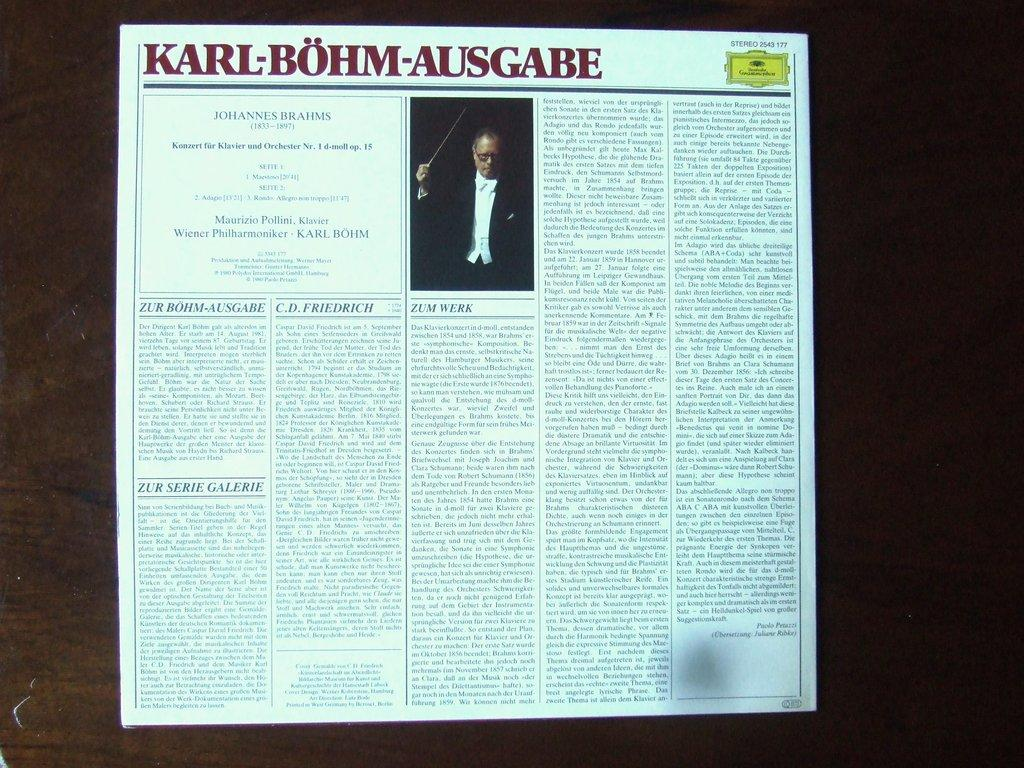What is the main subject in the center of the image? There is a newspaper in the center of the image. What can be found within the newspaper? There is a person wearing a black suit in the newspaper. What page of the newspaper is the person wearing a tank on? There is no person wearing a tank in the newspaper; the person is wearing a black suit. 